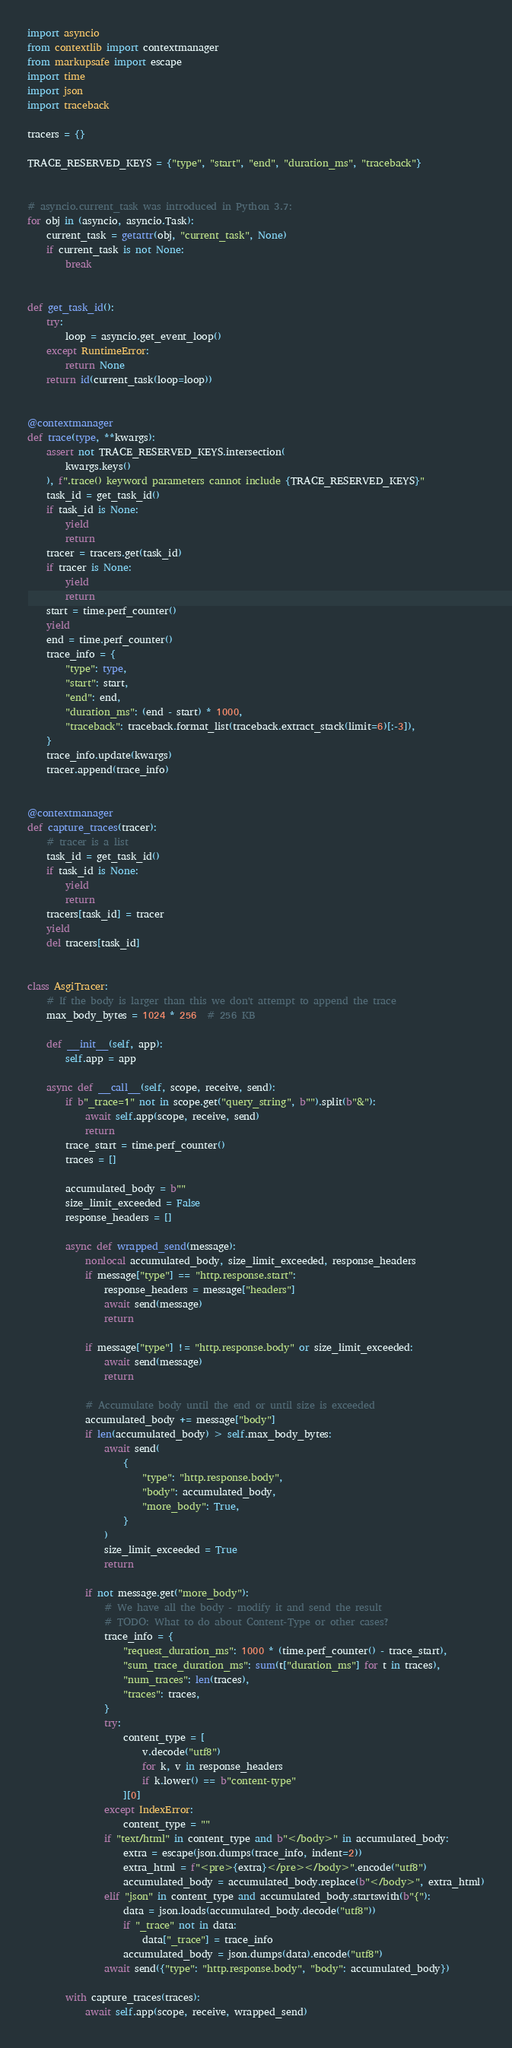Convert code to text. <code><loc_0><loc_0><loc_500><loc_500><_Python_>import asyncio
from contextlib import contextmanager
from markupsafe import escape
import time
import json
import traceback

tracers = {}

TRACE_RESERVED_KEYS = {"type", "start", "end", "duration_ms", "traceback"}


# asyncio.current_task was introduced in Python 3.7:
for obj in (asyncio, asyncio.Task):
    current_task = getattr(obj, "current_task", None)
    if current_task is not None:
        break


def get_task_id():
    try:
        loop = asyncio.get_event_loop()
    except RuntimeError:
        return None
    return id(current_task(loop=loop))


@contextmanager
def trace(type, **kwargs):
    assert not TRACE_RESERVED_KEYS.intersection(
        kwargs.keys()
    ), f".trace() keyword parameters cannot include {TRACE_RESERVED_KEYS}"
    task_id = get_task_id()
    if task_id is None:
        yield
        return
    tracer = tracers.get(task_id)
    if tracer is None:
        yield
        return
    start = time.perf_counter()
    yield
    end = time.perf_counter()
    trace_info = {
        "type": type,
        "start": start,
        "end": end,
        "duration_ms": (end - start) * 1000,
        "traceback": traceback.format_list(traceback.extract_stack(limit=6)[:-3]),
    }
    trace_info.update(kwargs)
    tracer.append(trace_info)


@contextmanager
def capture_traces(tracer):
    # tracer is a list
    task_id = get_task_id()
    if task_id is None:
        yield
        return
    tracers[task_id] = tracer
    yield
    del tracers[task_id]


class AsgiTracer:
    # If the body is larger than this we don't attempt to append the trace
    max_body_bytes = 1024 * 256  # 256 KB

    def __init__(self, app):
        self.app = app

    async def __call__(self, scope, receive, send):
        if b"_trace=1" not in scope.get("query_string", b"").split(b"&"):
            await self.app(scope, receive, send)
            return
        trace_start = time.perf_counter()
        traces = []

        accumulated_body = b""
        size_limit_exceeded = False
        response_headers = []

        async def wrapped_send(message):
            nonlocal accumulated_body, size_limit_exceeded, response_headers
            if message["type"] == "http.response.start":
                response_headers = message["headers"]
                await send(message)
                return

            if message["type"] != "http.response.body" or size_limit_exceeded:
                await send(message)
                return

            # Accumulate body until the end or until size is exceeded
            accumulated_body += message["body"]
            if len(accumulated_body) > self.max_body_bytes:
                await send(
                    {
                        "type": "http.response.body",
                        "body": accumulated_body,
                        "more_body": True,
                    }
                )
                size_limit_exceeded = True
                return

            if not message.get("more_body"):
                # We have all the body - modify it and send the result
                # TODO: What to do about Content-Type or other cases?
                trace_info = {
                    "request_duration_ms": 1000 * (time.perf_counter() - trace_start),
                    "sum_trace_duration_ms": sum(t["duration_ms"] for t in traces),
                    "num_traces": len(traces),
                    "traces": traces,
                }
                try:
                    content_type = [
                        v.decode("utf8")
                        for k, v in response_headers
                        if k.lower() == b"content-type"
                    ][0]
                except IndexError:
                    content_type = ""
                if "text/html" in content_type and b"</body>" in accumulated_body:
                    extra = escape(json.dumps(trace_info, indent=2))
                    extra_html = f"<pre>{extra}</pre></body>".encode("utf8")
                    accumulated_body = accumulated_body.replace(b"</body>", extra_html)
                elif "json" in content_type and accumulated_body.startswith(b"{"):
                    data = json.loads(accumulated_body.decode("utf8"))
                    if "_trace" not in data:
                        data["_trace"] = trace_info
                    accumulated_body = json.dumps(data).encode("utf8")
                await send({"type": "http.response.body", "body": accumulated_body})

        with capture_traces(traces):
            await self.app(scope, receive, wrapped_send)
</code> 